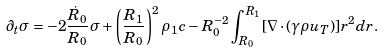<formula> <loc_0><loc_0><loc_500><loc_500>\partial _ { t } \sigma = - 2 \frac { \dot { R } _ { 0 } } { R _ { 0 } } \sigma + \left ( \frac { R _ { 1 } } { R _ { 0 } } \right ) ^ { 2 } \rho _ { 1 } c - R _ { 0 } ^ { - 2 } \int _ { R _ { 0 } } ^ { R _ { 1 } } [ { \nabla } \cdot ( \gamma \rho { u } _ { T } ) ] r ^ { 2 } d r .</formula> 